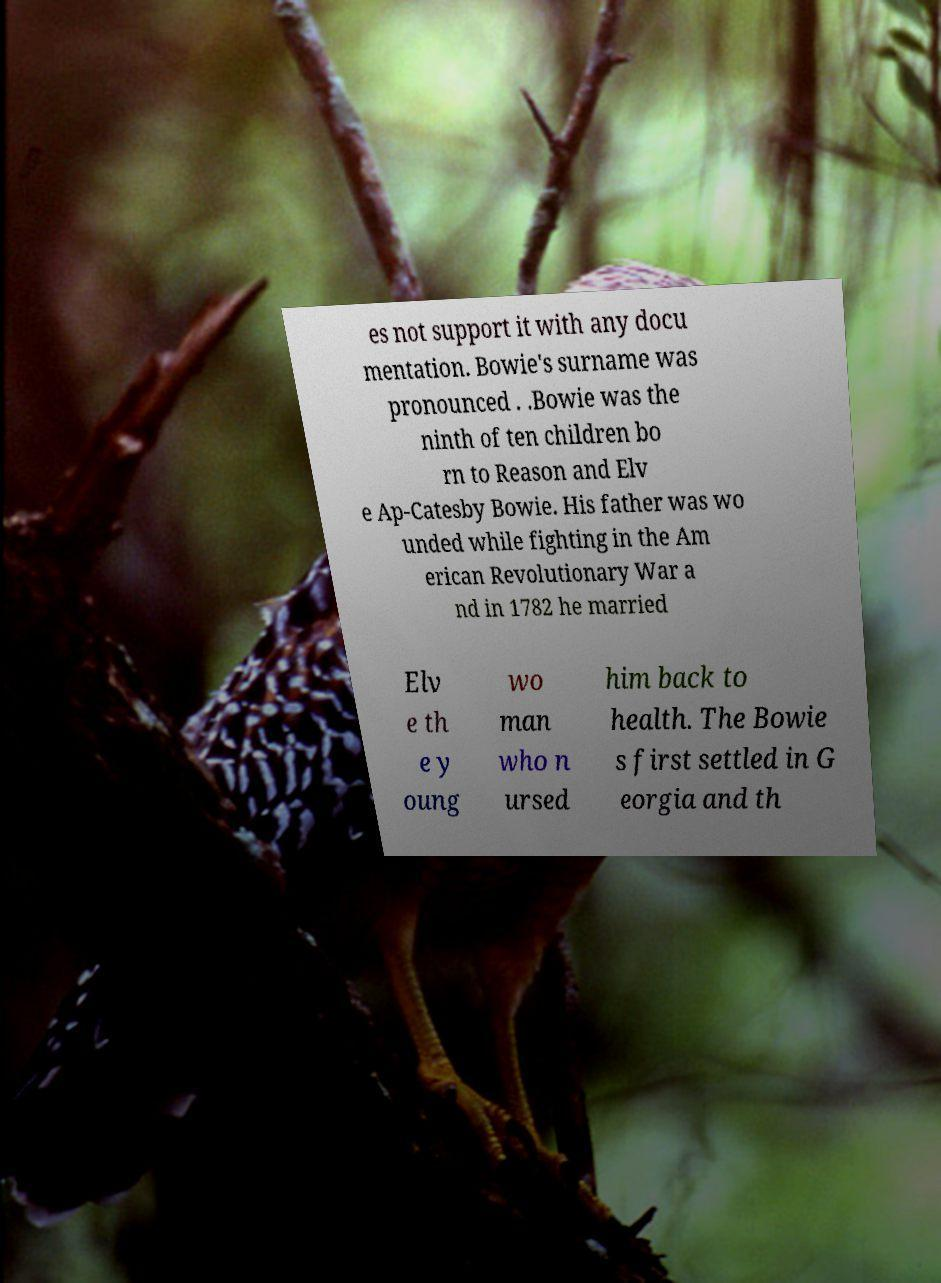I need the written content from this picture converted into text. Can you do that? es not support it with any docu mentation. Bowie's surname was pronounced . .Bowie was the ninth of ten children bo rn to Reason and Elv e Ap-Catesby Bowie. His father was wo unded while fighting in the Am erican Revolutionary War a nd in 1782 he married Elv e th e y oung wo man who n ursed him back to health. The Bowie s first settled in G eorgia and th 